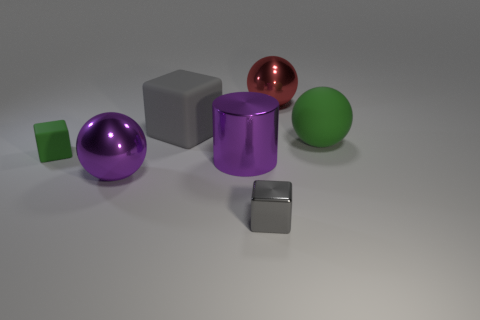Add 3 small rubber blocks. How many objects exist? 10 Subtract all brown balls. How many gray blocks are left? 2 Subtract all red shiny spheres. How many spheres are left? 2 Subtract 1 balls. How many balls are left? 2 Subtract all gray cubes. How many cubes are left? 1 Subtract all red cylinders. Subtract all red cubes. How many cylinders are left? 1 Subtract all green things. Subtract all big brown shiny cylinders. How many objects are left? 5 Add 4 purple spheres. How many purple spheres are left? 5 Add 6 big red shiny spheres. How many big red shiny spheres exist? 7 Subtract 0 purple cubes. How many objects are left? 7 